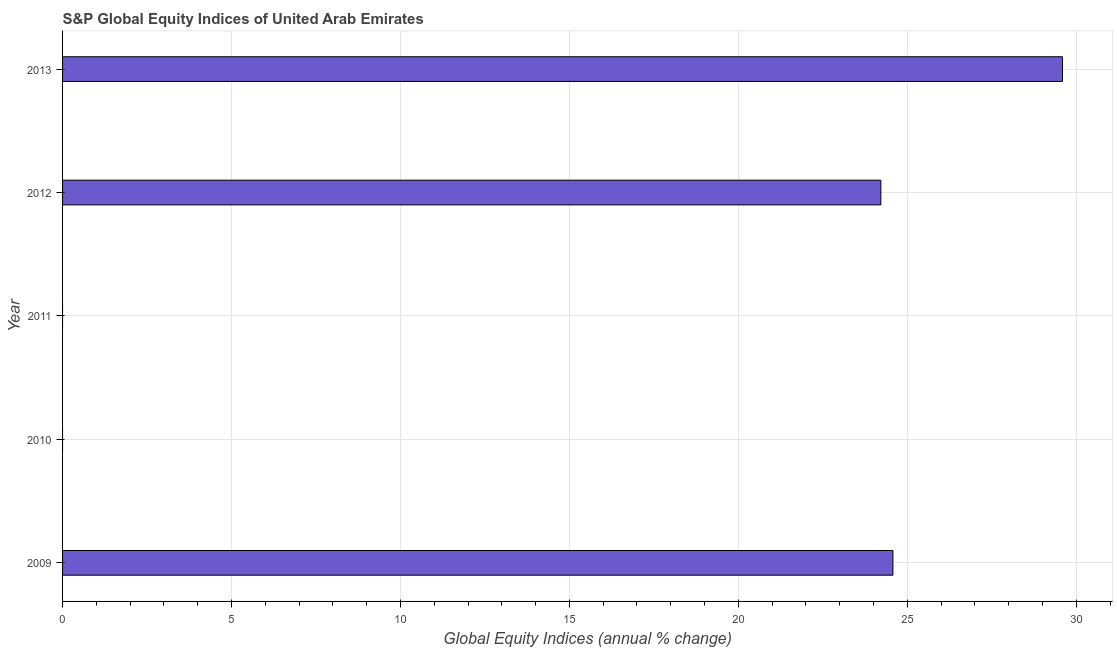Does the graph contain grids?
Keep it short and to the point. Yes. What is the title of the graph?
Provide a succinct answer. S&P Global Equity Indices of United Arab Emirates. What is the label or title of the X-axis?
Provide a succinct answer. Global Equity Indices (annual % change). Across all years, what is the maximum s&p global equity indices?
Keep it short and to the point. 29.59. In which year was the s&p global equity indices maximum?
Your response must be concise. 2013. What is the sum of the s&p global equity indices?
Provide a short and direct response. 78.38. What is the difference between the s&p global equity indices in 2009 and 2013?
Offer a very short reply. -5.02. What is the average s&p global equity indices per year?
Your response must be concise. 15.68. What is the median s&p global equity indices?
Your answer should be very brief. 24.22. What is the ratio of the s&p global equity indices in 2012 to that in 2013?
Offer a very short reply. 0.82. Is the difference between the s&p global equity indices in 2009 and 2012 greater than the difference between any two years?
Offer a terse response. No. What is the difference between the highest and the second highest s&p global equity indices?
Ensure brevity in your answer.  5.02. Is the sum of the s&p global equity indices in 2009 and 2012 greater than the maximum s&p global equity indices across all years?
Your answer should be compact. Yes. What is the difference between the highest and the lowest s&p global equity indices?
Give a very brief answer. 29.59. Are the values on the major ticks of X-axis written in scientific E-notation?
Offer a very short reply. No. What is the Global Equity Indices (annual % change) of 2009?
Your answer should be compact. 24.57. What is the Global Equity Indices (annual % change) in 2012?
Keep it short and to the point. 24.22. What is the Global Equity Indices (annual % change) in 2013?
Provide a short and direct response. 29.59. What is the difference between the Global Equity Indices (annual % change) in 2009 and 2012?
Your answer should be compact. 0.36. What is the difference between the Global Equity Indices (annual % change) in 2009 and 2013?
Give a very brief answer. -5.02. What is the difference between the Global Equity Indices (annual % change) in 2012 and 2013?
Your response must be concise. -5.38. What is the ratio of the Global Equity Indices (annual % change) in 2009 to that in 2012?
Provide a succinct answer. 1.01. What is the ratio of the Global Equity Indices (annual % change) in 2009 to that in 2013?
Keep it short and to the point. 0.83. What is the ratio of the Global Equity Indices (annual % change) in 2012 to that in 2013?
Your answer should be compact. 0.82. 